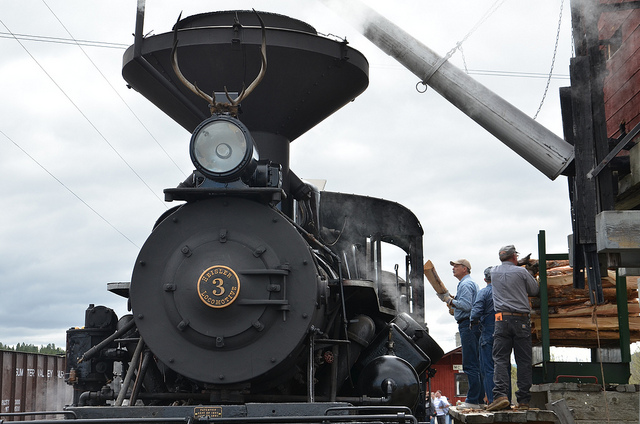Read and extract the text from this image. 3 